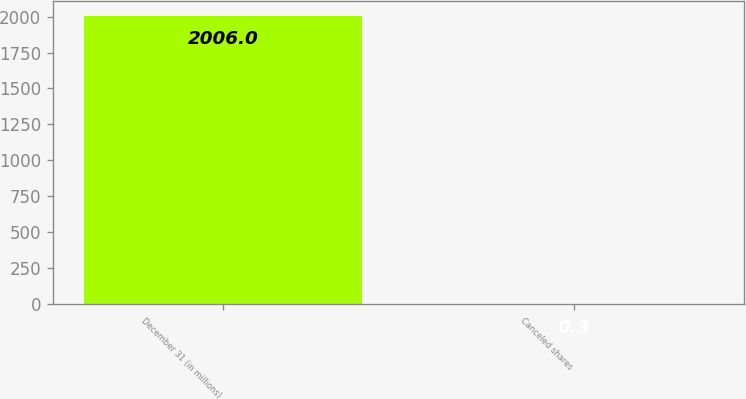<chart> <loc_0><loc_0><loc_500><loc_500><bar_chart><fcel>December 31 (in millions)<fcel>Canceled shares<nl><fcel>2006<fcel>0.3<nl></chart> 